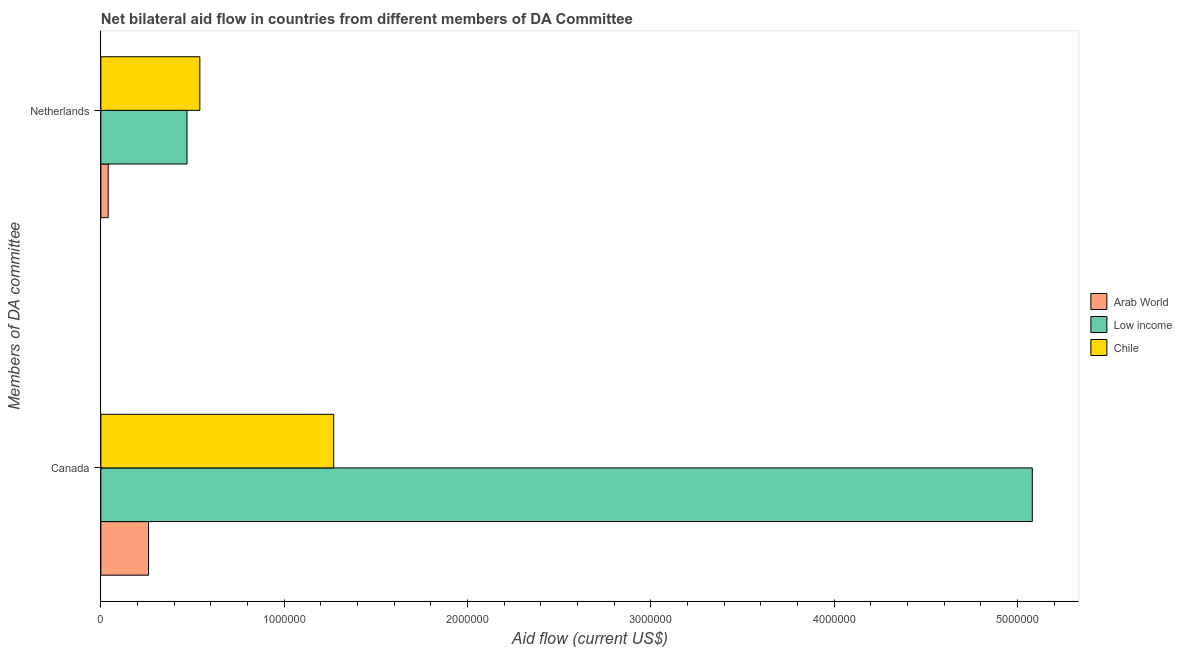How many groups of bars are there?
Offer a terse response. 2. Are the number of bars per tick equal to the number of legend labels?
Your answer should be compact. Yes. Are the number of bars on each tick of the Y-axis equal?
Provide a short and direct response. Yes. How many bars are there on the 1st tick from the top?
Offer a terse response. 3. What is the label of the 2nd group of bars from the top?
Make the answer very short. Canada. What is the amount of aid given by netherlands in Arab World?
Offer a very short reply. 4.00e+04. Across all countries, what is the maximum amount of aid given by canada?
Provide a short and direct response. 5.08e+06. Across all countries, what is the minimum amount of aid given by netherlands?
Your answer should be very brief. 4.00e+04. In which country was the amount of aid given by canada maximum?
Provide a succinct answer. Low income. In which country was the amount of aid given by netherlands minimum?
Your response must be concise. Arab World. What is the total amount of aid given by canada in the graph?
Keep it short and to the point. 6.61e+06. What is the difference between the amount of aid given by netherlands in Low income and that in Arab World?
Make the answer very short. 4.30e+05. What is the difference between the amount of aid given by canada in Low income and the amount of aid given by netherlands in Chile?
Provide a succinct answer. 4.54e+06. What is the average amount of aid given by canada per country?
Your answer should be compact. 2.20e+06. What is the difference between the amount of aid given by netherlands and amount of aid given by canada in Arab World?
Make the answer very short. -2.20e+05. In how many countries, is the amount of aid given by canada greater than 4200000 US$?
Your answer should be very brief. 1. Is the amount of aid given by canada in Arab World less than that in Low income?
Keep it short and to the point. Yes. What does the 2nd bar from the top in Netherlands represents?
Offer a very short reply. Low income. What does the 3rd bar from the bottom in Canada represents?
Your answer should be compact. Chile. Are all the bars in the graph horizontal?
Offer a terse response. Yes. How many countries are there in the graph?
Provide a short and direct response. 3. What is the difference between two consecutive major ticks on the X-axis?
Your answer should be compact. 1.00e+06. Does the graph contain any zero values?
Make the answer very short. No. Does the graph contain grids?
Your answer should be very brief. No. Where does the legend appear in the graph?
Your answer should be compact. Center right. How many legend labels are there?
Your answer should be compact. 3. What is the title of the graph?
Provide a succinct answer. Net bilateral aid flow in countries from different members of DA Committee. What is the label or title of the X-axis?
Ensure brevity in your answer.  Aid flow (current US$). What is the label or title of the Y-axis?
Provide a succinct answer. Members of DA committee. What is the Aid flow (current US$) in Arab World in Canada?
Your answer should be compact. 2.60e+05. What is the Aid flow (current US$) of Low income in Canada?
Your answer should be compact. 5.08e+06. What is the Aid flow (current US$) in Chile in Canada?
Offer a terse response. 1.27e+06. What is the Aid flow (current US$) in Chile in Netherlands?
Provide a short and direct response. 5.40e+05. Across all Members of DA committee, what is the maximum Aid flow (current US$) in Low income?
Your answer should be very brief. 5.08e+06. Across all Members of DA committee, what is the maximum Aid flow (current US$) of Chile?
Your answer should be very brief. 1.27e+06. Across all Members of DA committee, what is the minimum Aid flow (current US$) of Arab World?
Give a very brief answer. 4.00e+04. Across all Members of DA committee, what is the minimum Aid flow (current US$) of Chile?
Keep it short and to the point. 5.40e+05. What is the total Aid flow (current US$) in Arab World in the graph?
Your answer should be very brief. 3.00e+05. What is the total Aid flow (current US$) in Low income in the graph?
Offer a terse response. 5.55e+06. What is the total Aid flow (current US$) in Chile in the graph?
Give a very brief answer. 1.81e+06. What is the difference between the Aid flow (current US$) of Arab World in Canada and that in Netherlands?
Provide a succinct answer. 2.20e+05. What is the difference between the Aid flow (current US$) in Low income in Canada and that in Netherlands?
Offer a terse response. 4.61e+06. What is the difference between the Aid flow (current US$) of Chile in Canada and that in Netherlands?
Provide a short and direct response. 7.30e+05. What is the difference between the Aid flow (current US$) of Arab World in Canada and the Aid flow (current US$) of Chile in Netherlands?
Ensure brevity in your answer.  -2.80e+05. What is the difference between the Aid flow (current US$) in Low income in Canada and the Aid flow (current US$) in Chile in Netherlands?
Provide a short and direct response. 4.54e+06. What is the average Aid flow (current US$) in Low income per Members of DA committee?
Your answer should be compact. 2.78e+06. What is the average Aid flow (current US$) in Chile per Members of DA committee?
Ensure brevity in your answer.  9.05e+05. What is the difference between the Aid flow (current US$) of Arab World and Aid flow (current US$) of Low income in Canada?
Offer a terse response. -4.82e+06. What is the difference between the Aid flow (current US$) of Arab World and Aid flow (current US$) of Chile in Canada?
Make the answer very short. -1.01e+06. What is the difference between the Aid flow (current US$) of Low income and Aid flow (current US$) of Chile in Canada?
Give a very brief answer. 3.81e+06. What is the difference between the Aid flow (current US$) of Arab World and Aid flow (current US$) of Low income in Netherlands?
Ensure brevity in your answer.  -4.30e+05. What is the difference between the Aid flow (current US$) of Arab World and Aid flow (current US$) of Chile in Netherlands?
Give a very brief answer. -5.00e+05. What is the difference between the Aid flow (current US$) in Low income and Aid flow (current US$) in Chile in Netherlands?
Offer a very short reply. -7.00e+04. What is the ratio of the Aid flow (current US$) in Low income in Canada to that in Netherlands?
Offer a terse response. 10.81. What is the ratio of the Aid flow (current US$) of Chile in Canada to that in Netherlands?
Provide a short and direct response. 2.35. What is the difference between the highest and the second highest Aid flow (current US$) of Arab World?
Offer a very short reply. 2.20e+05. What is the difference between the highest and the second highest Aid flow (current US$) in Low income?
Make the answer very short. 4.61e+06. What is the difference between the highest and the second highest Aid flow (current US$) of Chile?
Keep it short and to the point. 7.30e+05. What is the difference between the highest and the lowest Aid flow (current US$) of Low income?
Your answer should be compact. 4.61e+06. What is the difference between the highest and the lowest Aid flow (current US$) of Chile?
Offer a very short reply. 7.30e+05. 